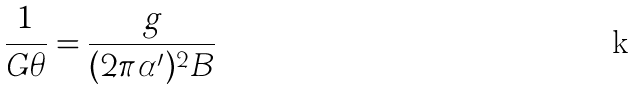<formula> <loc_0><loc_0><loc_500><loc_500>\frac { 1 } { G \theta } = \frac { g } { ( 2 \pi \alpha ^ { \prime } ) ^ { 2 } B }</formula> 